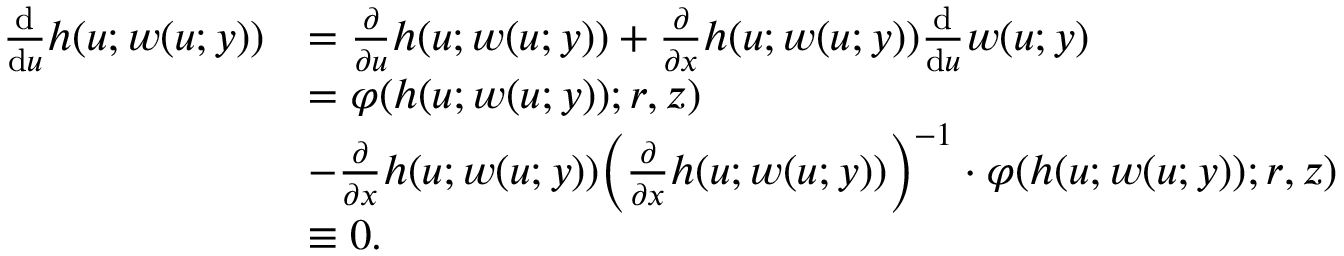Convert formula to latex. <formula><loc_0><loc_0><loc_500><loc_500>\begin{array} { r l } { \frac { d } { d u } h ( u ; w ( u ; y ) ) } & { = \frac { \partial } { \partial u } h ( u ; w ( u ; y ) ) + \frac { \partial } { \partial x } h ( u ; w ( u ; y ) ) \frac { d } { d u } w ( u ; y ) } \\ & { = \varphi ( h ( u ; w ( u ; y ) ) ; r , z ) } \\ & { - \frac { \partial } { \partial x } h ( u ; w ( u ; y ) ) \left ( \frac { \partial } { \partial x } h ( u ; w ( u ; y ) ) \right ) ^ { - 1 } \cdot \varphi ( h ( u ; w ( u ; y ) ) ; r , z ) } \\ & { \equiv 0 . } \end{array}</formula> 